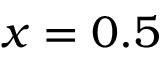Convert formula to latex. <formula><loc_0><loc_0><loc_500><loc_500>x = 0 . 5</formula> 